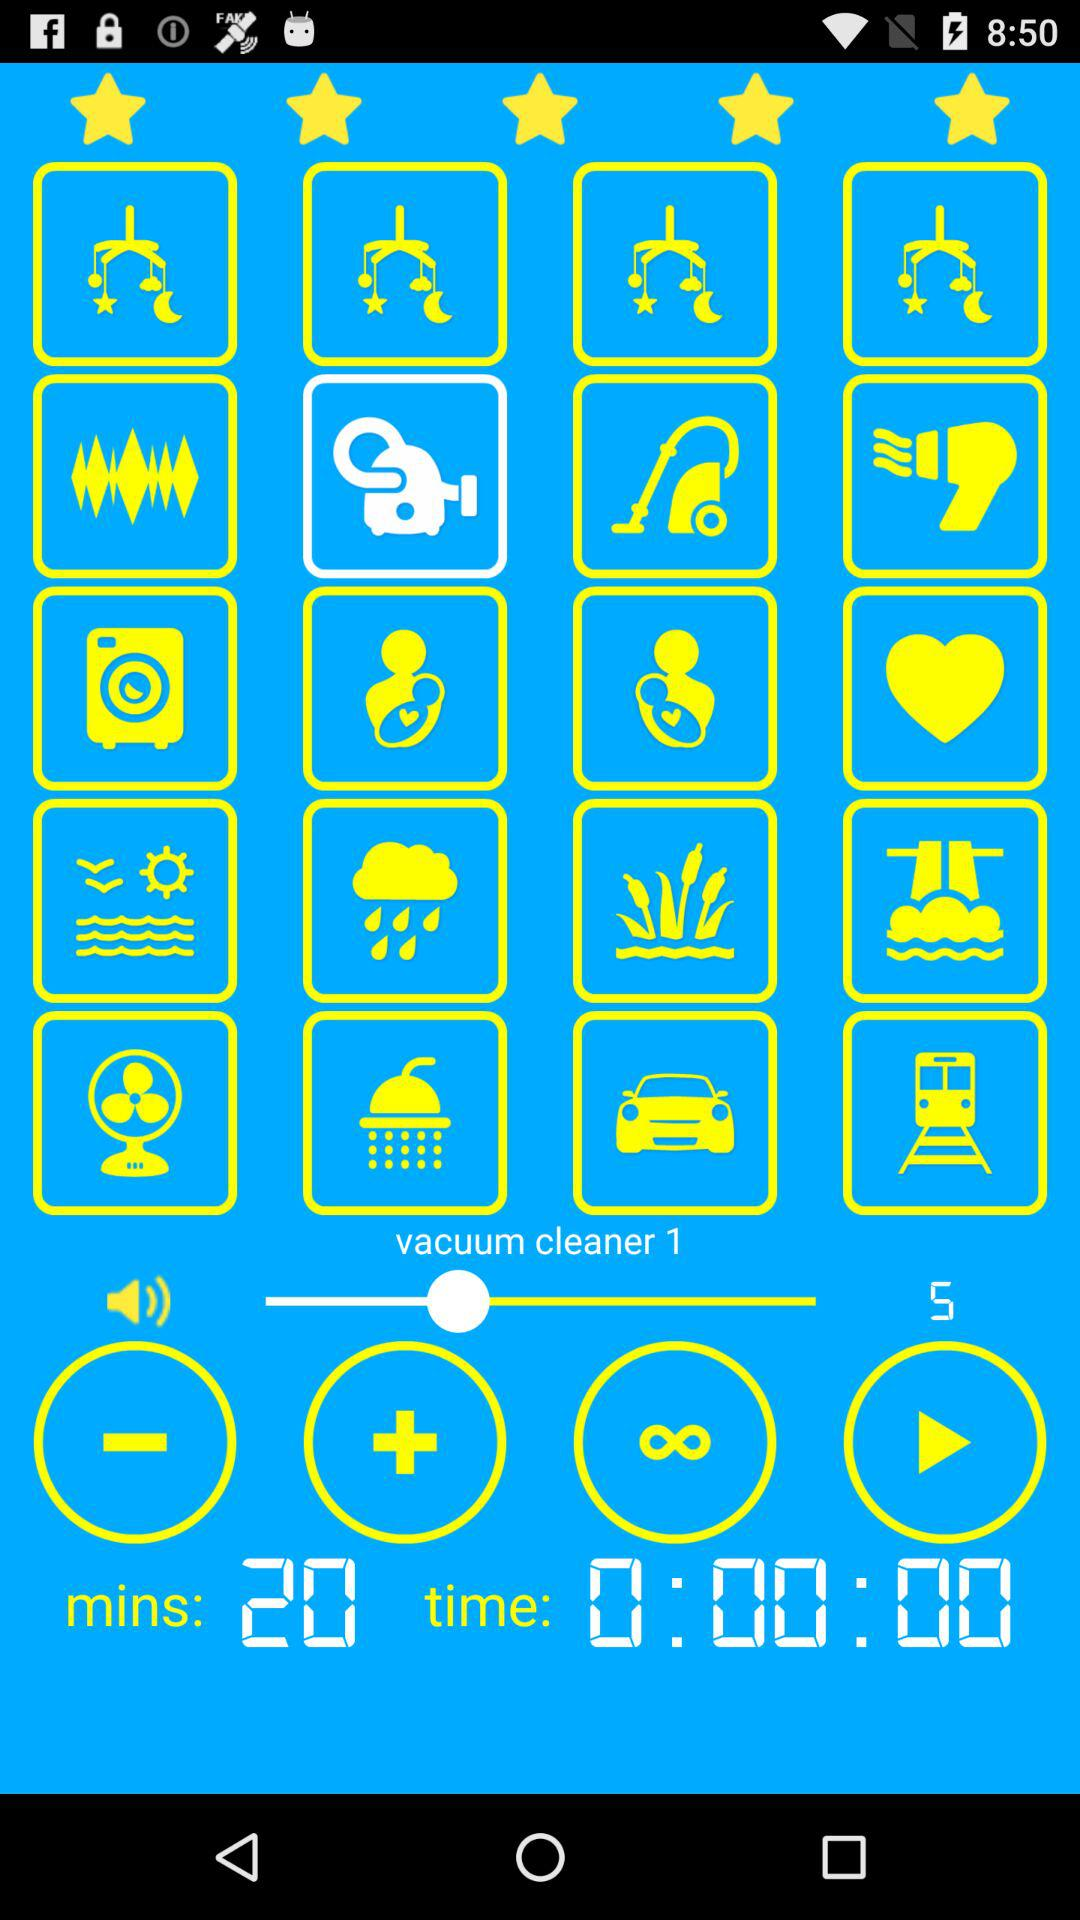What is the number of selected vacuum cleaners? The number of selected vacuum cleaners is 1. 